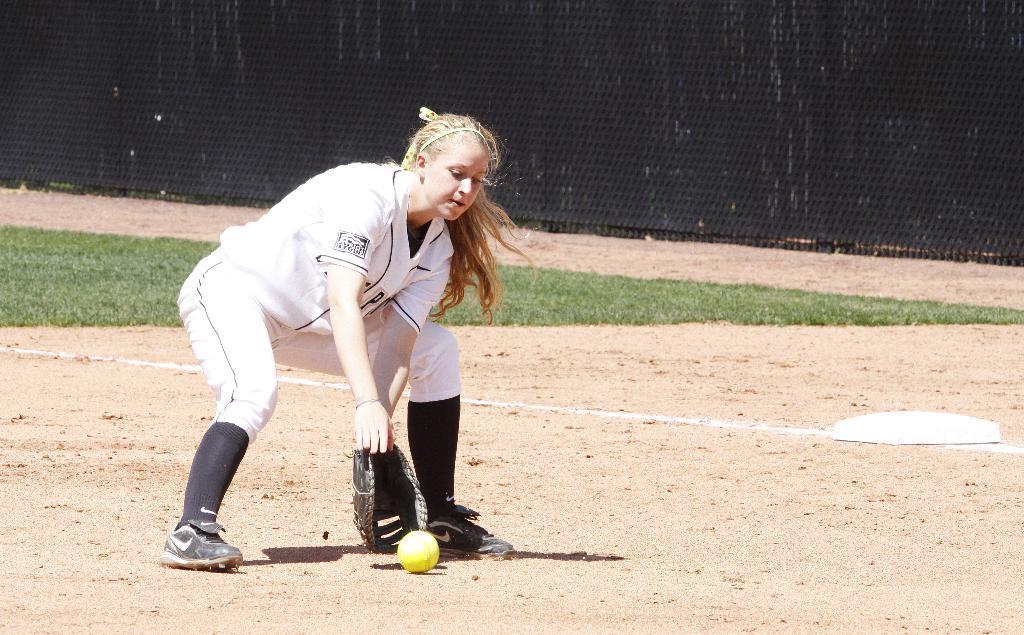Could you give a brief overview of what you see in this image? In this picture we can observe a woman standing in the ground. She is wearing white color dress and a glove to her hand. We can observe yellow color wall here. There is some grass on the ground. In the background we can observe a black color fence. 